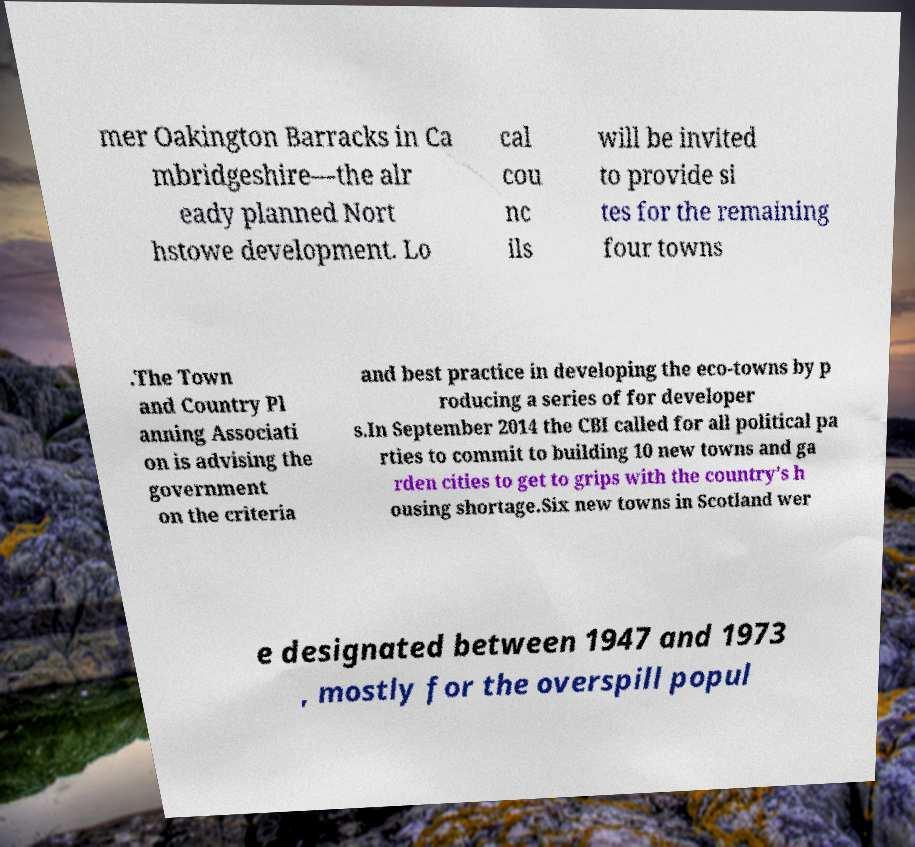Can you read and provide the text displayed in the image?This photo seems to have some interesting text. Can you extract and type it out for me? mer Oakington Barracks in Ca mbridgeshire—the alr eady planned Nort hstowe development. Lo cal cou nc ils will be invited to provide si tes for the remaining four towns .The Town and Country Pl anning Associati on is advising the government on the criteria and best practice in developing the eco-towns by p roducing a series of for developer s.In September 2014 the CBI called for all political pa rties to commit to building 10 new towns and ga rden cities to get to grips with the country's h ousing shortage.Six new towns in Scotland wer e designated between 1947 and 1973 , mostly for the overspill popul 